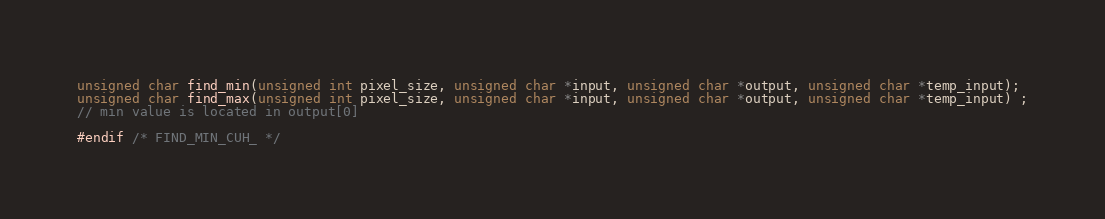Convert code to text. <code><loc_0><loc_0><loc_500><loc_500><_Cuda_>unsigned char find_min(unsigned int pixel_size, unsigned char *input, unsigned char *output, unsigned char *temp_input);
unsigned char find_max(unsigned int pixel_size, unsigned char *input, unsigned char *output, unsigned char *temp_input) ;
// min value is located in output[0]

#endif /* FIND_MIN_CUH_ */
</code> 